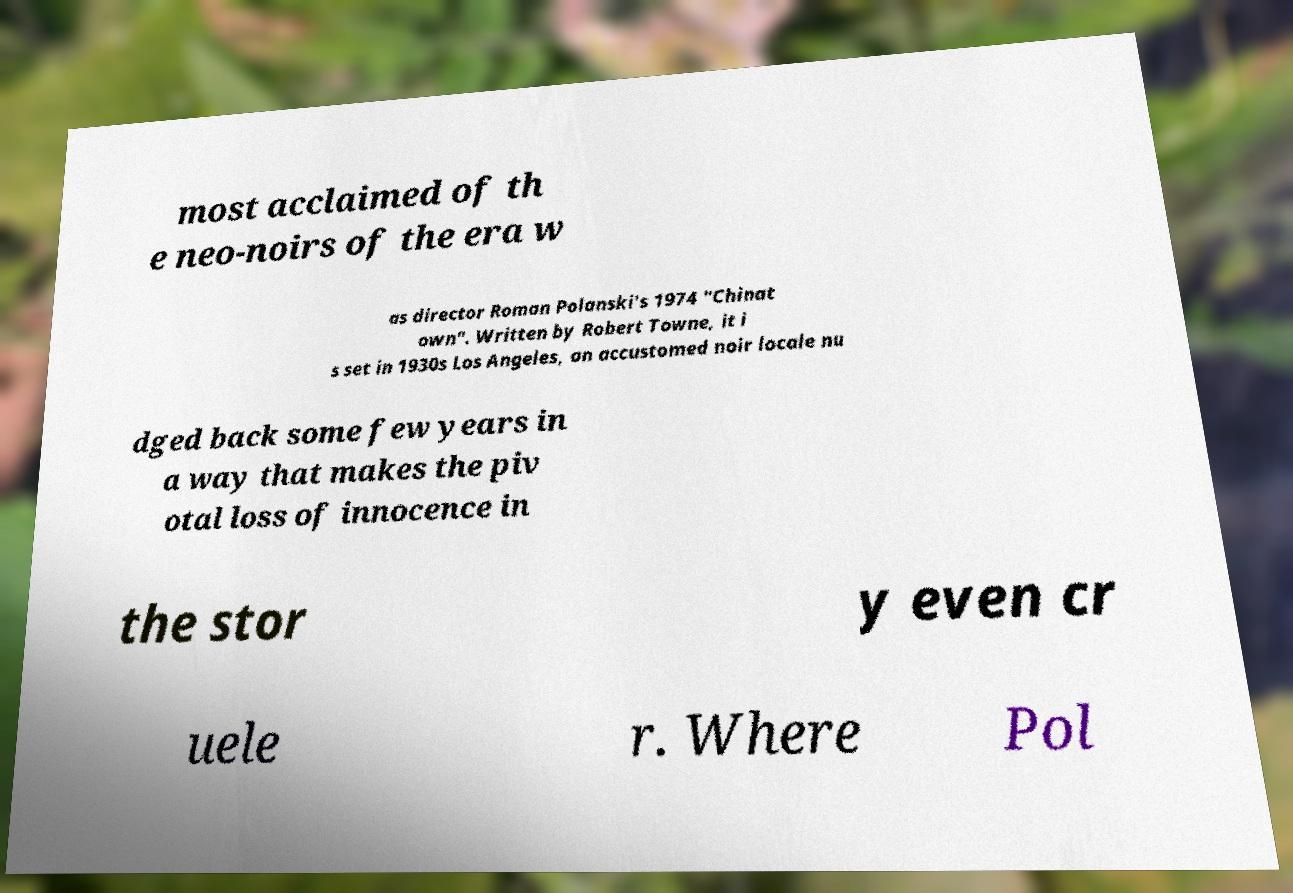I need the written content from this picture converted into text. Can you do that? most acclaimed of th e neo-noirs of the era w as director Roman Polanski's 1974 "Chinat own". Written by Robert Towne, it i s set in 1930s Los Angeles, an accustomed noir locale nu dged back some few years in a way that makes the piv otal loss of innocence in the stor y even cr uele r. Where Pol 